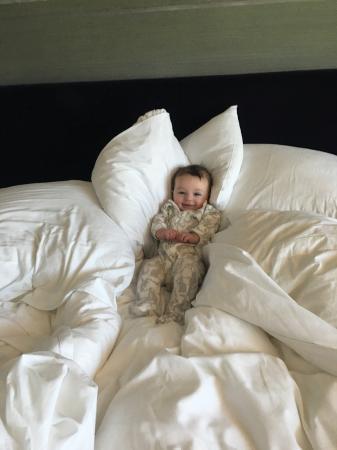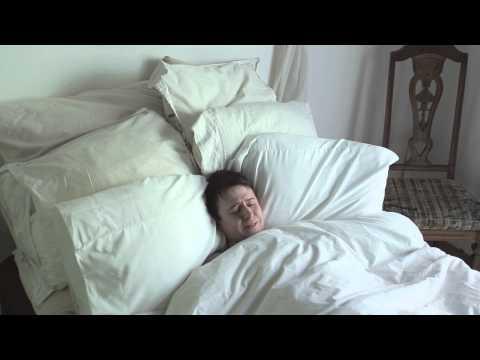The first image is the image on the left, the second image is the image on the right. Given the left and right images, does the statement "A image shows a pillow with a 3D embellishment." hold true? Answer yes or no. No. The first image is the image on the left, the second image is the image on the right. For the images shown, is this caption "There are at least six pillows in the image on the right" true? Answer yes or no. Yes. 